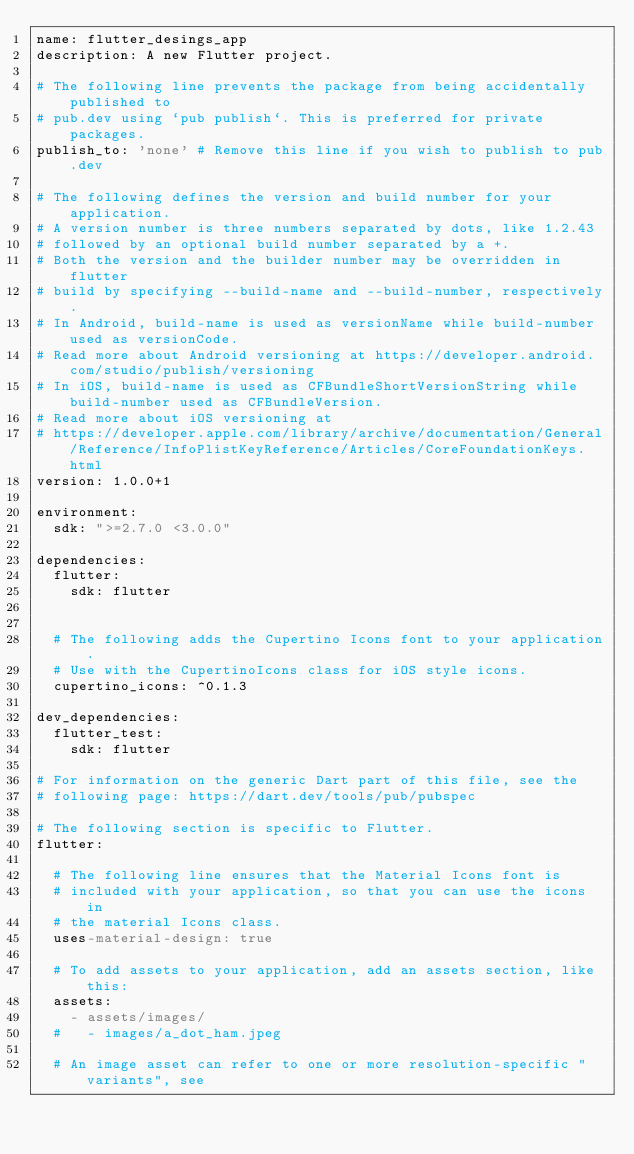Convert code to text. <code><loc_0><loc_0><loc_500><loc_500><_YAML_>name: flutter_desings_app
description: A new Flutter project.

# The following line prevents the package from being accidentally published to
# pub.dev using `pub publish`. This is preferred for private packages.
publish_to: 'none' # Remove this line if you wish to publish to pub.dev

# The following defines the version and build number for your application.
# A version number is three numbers separated by dots, like 1.2.43
# followed by an optional build number separated by a +.
# Both the version and the builder number may be overridden in flutter
# build by specifying --build-name and --build-number, respectively.
# In Android, build-name is used as versionName while build-number used as versionCode.
# Read more about Android versioning at https://developer.android.com/studio/publish/versioning
# In iOS, build-name is used as CFBundleShortVersionString while build-number used as CFBundleVersion.
# Read more about iOS versioning at
# https://developer.apple.com/library/archive/documentation/General/Reference/InfoPlistKeyReference/Articles/CoreFoundationKeys.html
version: 1.0.0+1

environment:
  sdk: ">=2.7.0 <3.0.0"

dependencies:
  flutter:
    sdk: flutter


  # The following adds the Cupertino Icons font to your application.
  # Use with the CupertinoIcons class for iOS style icons.
  cupertino_icons: ^0.1.3

dev_dependencies:
  flutter_test:
    sdk: flutter

# For information on the generic Dart part of this file, see the
# following page: https://dart.dev/tools/pub/pubspec

# The following section is specific to Flutter.
flutter:

  # The following line ensures that the Material Icons font is
  # included with your application, so that you can use the icons in
  # the material Icons class.
  uses-material-design: true

  # To add assets to your application, add an assets section, like this:
  assets:
    - assets/images/
  #   - images/a_dot_ham.jpeg

  # An image asset can refer to one or more resolution-specific "variants", see</code> 